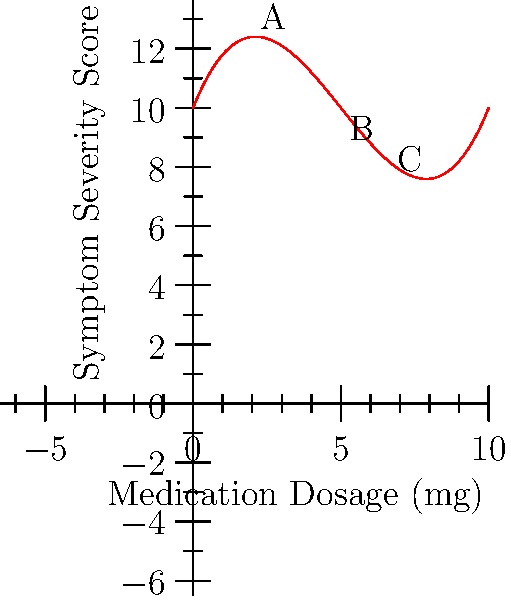The graph above represents the relationship between medication dosage and symptom severity for a specific affective disorder. Which point on the curve (A, B, or C) represents the optimal medication dosage for minimizing symptom severity, and what does this suggest about the pharmacodynamics of this medication? To answer this question, we need to analyze the polynomial regression curve and understand its implications:

1. The curve represents a third-degree polynomial function, indicating a complex relationship between medication dosage and symptom severity.

2. Point A (around 2mg dosage): High symptom severity, suggesting insufficient medication.

3. Point B (around 5mg dosage): Lowest point on the curve, indicating minimum symptom severity.

4. Point C (around 8mg dosage): Increased symptom severity compared to B, suggesting potential overdosage or diminishing returns.

5. The optimal dosage is represented by point B, where symptom severity is at its lowest.

6. This U-shaped curve suggests:
   a) At low doses, the medication is ineffective (left of B).
   b) At optimal doses, symptoms are minimized (point B).
   c) At high doses, side effects or diminishing efficacy occur (right of B).

7. Pharmacodynamically, this implies:
   a) The medication has a narrow therapeutic window.
   b) There's a non-linear relationship between dosage and effect.
   c) Individualized dosing is crucial to balance efficacy and side effects.
Answer: Point B; indicates narrow therapeutic window and non-linear dose-response relationship. 